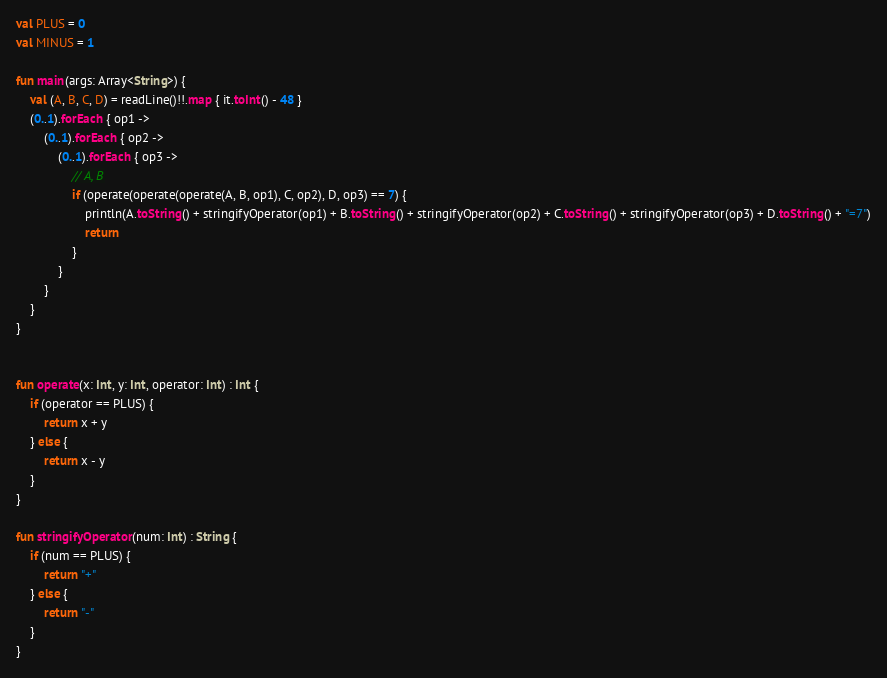<code> <loc_0><loc_0><loc_500><loc_500><_Kotlin_>val PLUS = 0
val MINUS = 1

fun main(args: Array<String>) {
    val (A, B, C, D) = readLine()!!.map { it.toInt() - 48 }
    (0..1).forEach { op1 ->
        (0..1).forEach { op2 ->
            (0..1).forEach { op3 ->
                // A, B
                if (operate(operate(operate(A, B, op1), C, op2), D, op3) == 7) {
                    println(A.toString() + stringifyOperator(op1) + B.toString() + stringifyOperator(op2) + C.toString() + stringifyOperator(op3) + D.toString() + "=7")
                    return
                }
            }
        }
    }
}


fun operate(x: Int, y: Int, operator: Int) : Int {
    if (operator == PLUS) {
        return x + y
    } else {
        return x - y
    }
}

fun stringifyOperator(num: Int) : String {
    if (num == PLUS) {
        return "+"
    } else {
        return "-"
    }
}</code> 